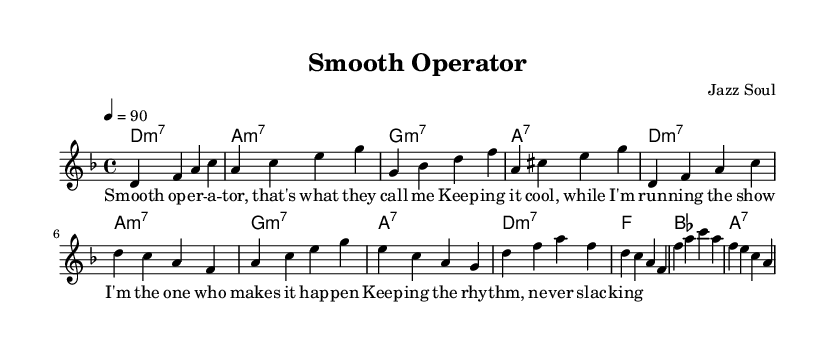What is the key signature of this music? The key signature shown in the score is D minor, which typically has one flat (B flat) as indicated in the key signature at the beginning of the staff.
Answer: D minor What is the time signature of this piece? The time signature, located at the beginning of the score, is 4/4, which indicates there are four beats per measure and a quarter note receives one beat.
Answer: 4/4 What is the tempo marking for this piece? The tempo marking appears at the beginning and indicates that the piece should be played at a speed of 90 beats per minute, which is common in soul music to maintain a laid-back groove.
Answer: 90 What type of chord is used in the introduction? The chords listed in the introduction section are D minor 7, A minor 7, G minor 7, and A7 as indicated in the chord changes section at the start of the score.
Answer: minor 7 How many measures are in the verse section? The verse section consists of four measures, as can be counted from the melody and chord notation presented under the verse header.
Answer: 4 What is the primary lyrical theme of the chorus? The chorus lyrics revolve around maintaining rhythm and ensuring that everything runs smoothly, reflecting common themes in soul music about control and groove as stated in the lyrics.
Answer: smooth operations Which section follows the verse? Based on the arrangement in the score, the chorus directly follows the verse section, indicating a common structure in songwriting where verses lead into choruses for emphasis.
Answer: chorus 